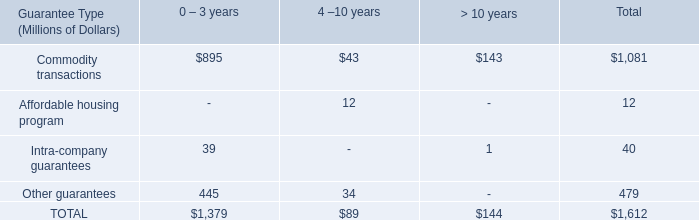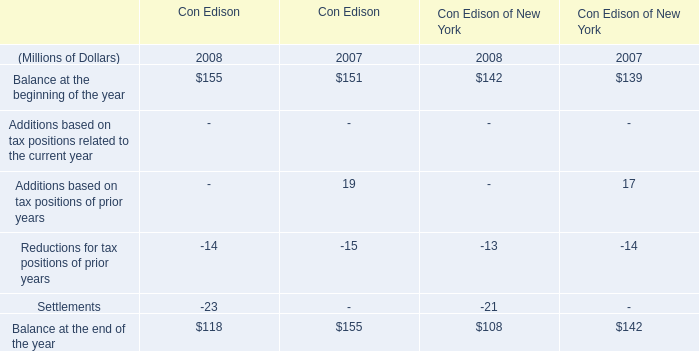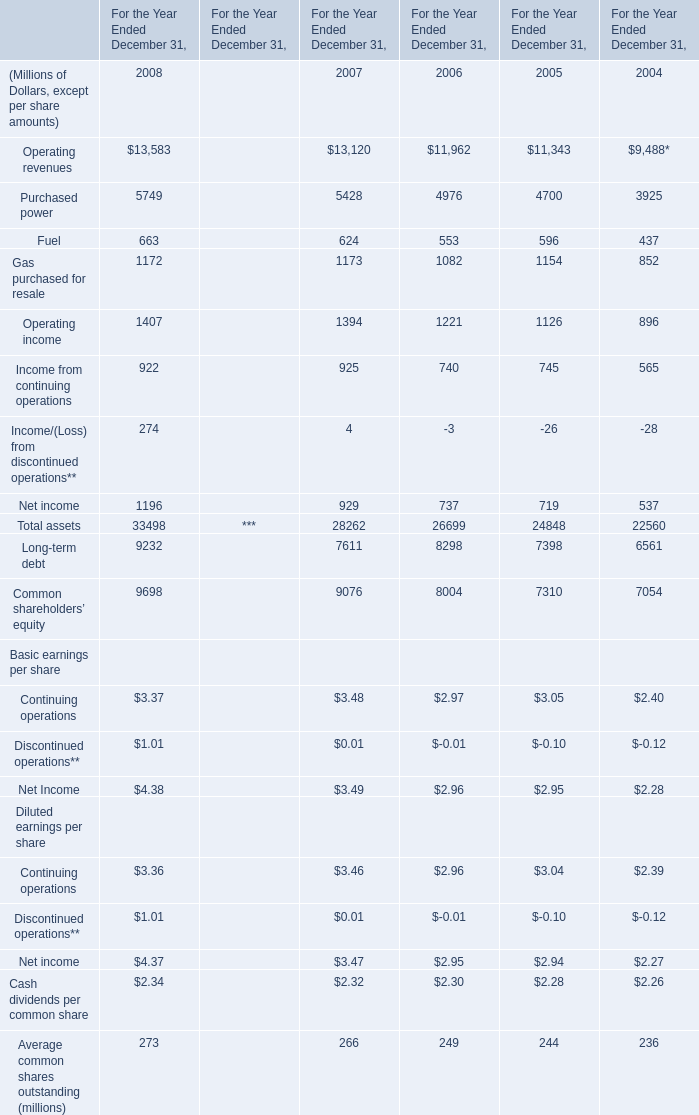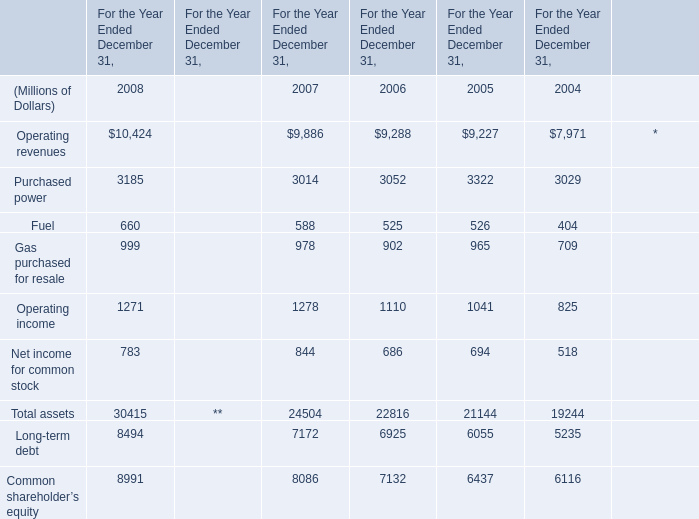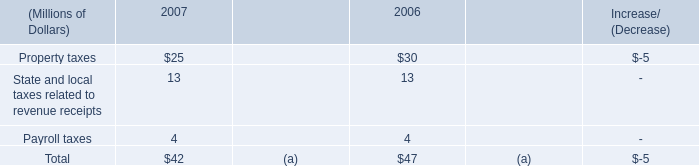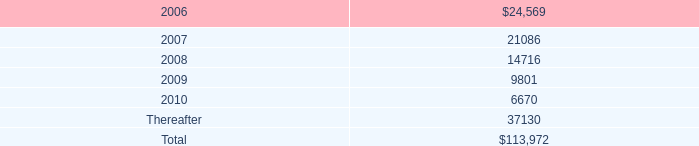What's the sum of Purchased power of For the Year Ended December 31, 2008, Purchased power of For the Year Ended December 31, 2008, and Operating revenues of For the Year Ended December 31, 2005 ? 
Computations: ((5749.0 + 3185.0) + 9227.0)
Answer: 18161.0. 